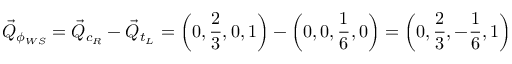<formula> <loc_0><loc_0><loc_500><loc_500>\vec { Q } _ { \phi _ { W S } } = \vec { Q } _ { c _ { R } } - \vec { Q } _ { t _ { L } } = \left ( 0 , \frac { 2 } { 3 } , 0 , 1 \right ) - \left ( 0 , 0 , \frac { 1 } { 6 } , 0 \right ) = \left ( 0 , \frac { 2 } { 3 } , - \frac { 1 } { 6 } , 1 \right )</formula> 